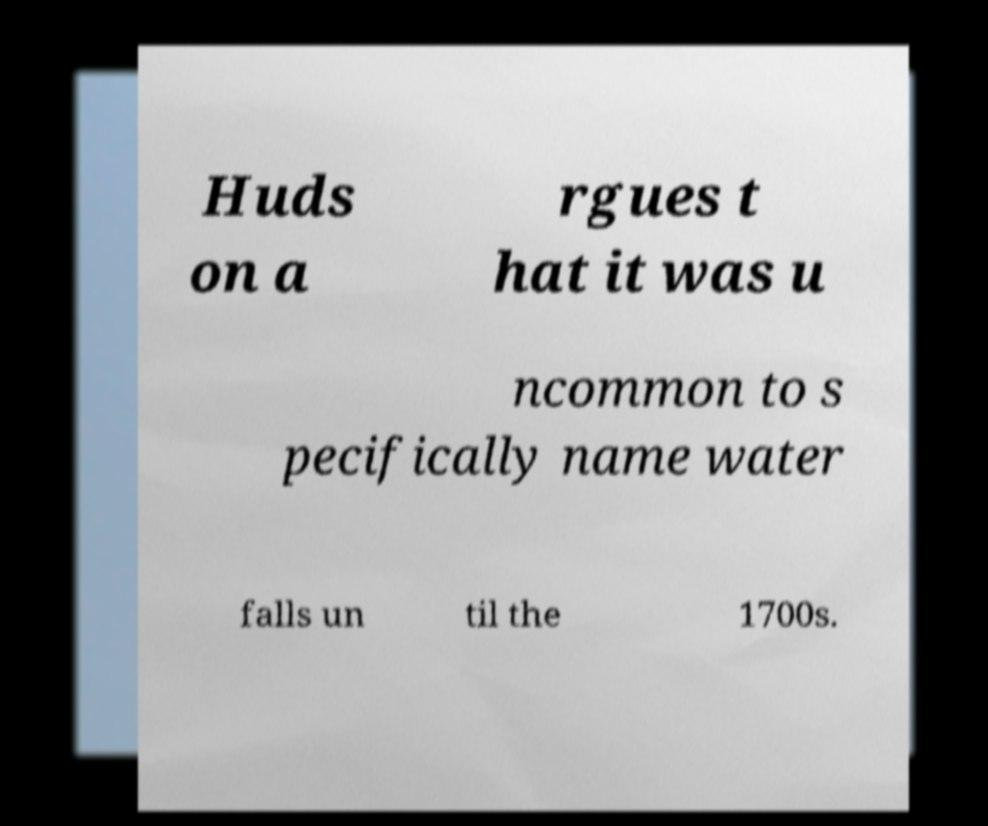For documentation purposes, I need the text within this image transcribed. Could you provide that? Huds on a rgues t hat it was u ncommon to s pecifically name water falls un til the 1700s. 